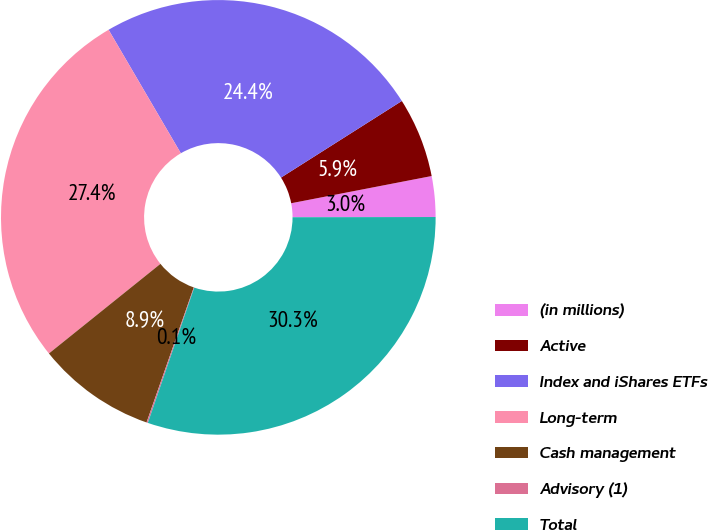Convert chart. <chart><loc_0><loc_0><loc_500><loc_500><pie_chart><fcel>(in millions)<fcel>Active<fcel>Index and iShares ETFs<fcel>Long-term<fcel>Cash management<fcel>Advisory (1)<fcel>Total<nl><fcel>3.02%<fcel>5.95%<fcel>24.43%<fcel>27.35%<fcel>8.87%<fcel>0.1%<fcel>30.28%<nl></chart> 